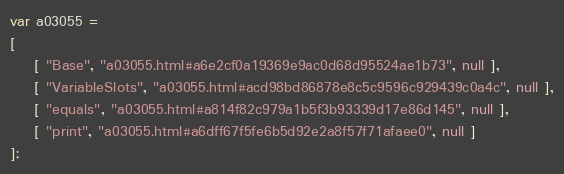<code> <loc_0><loc_0><loc_500><loc_500><_JavaScript_>var a03055 =
[
    [ "Base", "a03055.html#a6e2cf0a19369e9ac0d68d95524ae1b73", null ],
    [ "VariableSlots", "a03055.html#acd98bd86878e8c5c9596c929439c0a4c", null ],
    [ "equals", "a03055.html#a814f82c979a1b5f3b93339d17e86d145", null ],
    [ "print", "a03055.html#a6dff67f5fe6b5d92e2a8f57f71afaee0", null ]
];</code> 